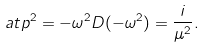<formula> <loc_0><loc_0><loc_500><loc_500>a t p ^ { 2 } = - \omega ^ { 2 } D ( - \omega ^ { 2 } ) = \frac { i } { \mu ^ { 2 } } .</formula> 